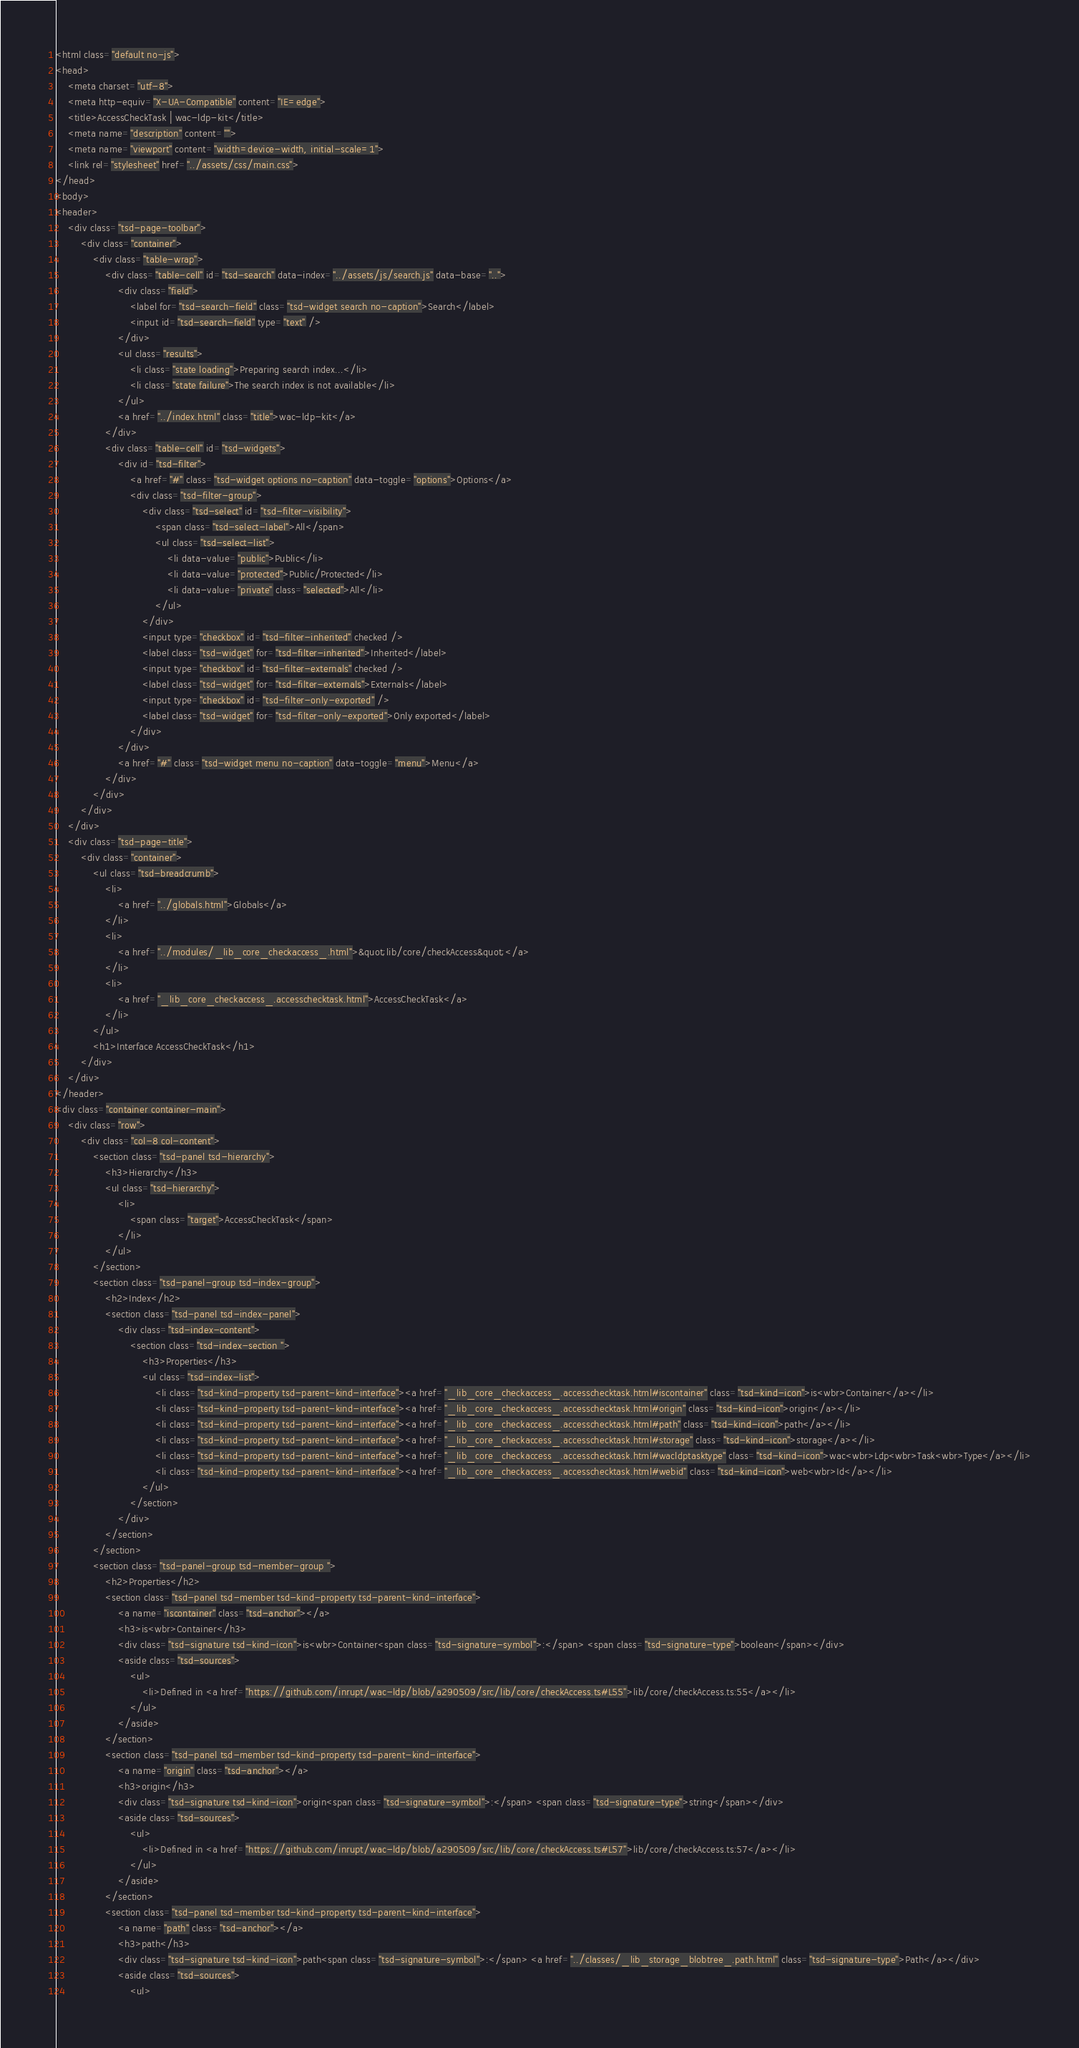Convert code to text. <code><loc_0><loc_0><loc_500><loc_500><_HTML_><html class="default no-js">
<head>
	<meta charset="utf-8">
	<meta http-equiv="X-UA-Compatible" content="IE=edge">
	<title>AccessCheckTask | wac-ldp-kit</title>
	<meta name="description" content="">
	<meta name="viewport" content="width=device-width, initial-scale=1">
	<link rel="stylesheet" href="../assets/css/main.css">
</head>
<body>
<header>
	<div class="tsd-page-toolbar">
		<div class="container">
			<div class="table-wrap">
				<div class="table-cell" id="tsd-search" data-index="../assets/js/search.js" data-base="..">
					<div class="field">
						<label for="tsd-search-field" class="tsd-widget search no-caption">Search</label>
						<input id="tsd-search-field" type="text" />
					</div>
					<ul class="results">
						<li class="state loading">Preparing search index...</li>
						<li class="state failure">The search index is not available</li>
					</ul>
					<a href="../index.html" class="title">wac-ldp-kit</a>
				</div>
				<div class="table-cell" id="tsd-widgets">
					<div id="tsd-filter">
						<a href="#" class="tsd-widget options no-caption" data-toggle="options">Options</a>
						<div class="tsd-filter-group">
							<div class="tsd-select" id="tsd-filter-visibility">
								<span class="tsd-select-label">All</span>
								<ul class="tsd-select-list">
									<li data-value="public">Public</li>
									<li data-value="protected">Public/Protected</li>
									<li data-value="private" class="selected">All</li>
								</ul>
							</div>
							<input type="checkbox" id="tsd-filter-inherited" checked />
							<label class="tsd-widget" for="tsd-filter-inherited">Inherited</label>
							<input type="checkbox" id="tsd-filter-externals" checked />
							<label class="tsd-widget" for="tsd-filter-externals">Externals</label>
							<input type="checkbox" id="tsd-filter-only-exported" />
							<label class="tsd-widget" for="tsd-filter-only-exported">Only exported</label>
						</div>
					</div>
					<a href="#" class="tsd-widget menu no-caption" data-toggle="menu">Menu</a>
				</div>
			</div>
		</div>
	</div>
	<div class="tsd-page-title">
		<div class="container">
			<ul class="tsd-breadcrumb">
				<li>
					<a href="../globals.html">Globals</a>
				</li>
				<li>
					<a href="../modules/_lib_core_checkaccess_.html">&quot;lib/core/checkAccess&quot;</a>
				</li>
				<li>
					<a href="_lib_core_checkaccess_.accesschecktask.html">AccessCheckTask</a>
				</li>
			</ul>
			<h1>Interface AccessCheckTask</h1>
		</div>
	</div>
</header>
<div class="container container-main">
	<div class="row">
		<div class="col-8 col-content">
			<section class="tsd-panel tsd-hierarchy">
				<h3>Hierarchy</h3>
				<ul class="tsd-hierarchy">
					<li>
						<span class="target">AccessCheckTask</span>
					</li>
				</ul>
			</section>
			<section class="tsd-panel-group tsd-index-group">
				<h2>Index</h2>
				<section class="tsd-panel tsd-index-panel">
					<div class="tsd-index-content">
						<section class="tsd-index-section ">
							<h3>Properties</h3>
							<ul class="tsd-index-list">
								<li class="tsd-kind-property tsd-parent-kind-interface"><a href="_lib_core_checkaccess_.accesschecktask.html#iscontainer" class="tsd-kind-icon">is<wbr>Container</a></li>
								<li class="tsd-kind-property tsd-parent-kind-interface"><a href="_lib_core_checkaccess_.accesschecktask.html#origin" class="tsd-kind-icon">origin</a></li>
								<li class="tsd-kind-property tsd-parent-kind-interface"><a href="_lib_core_checkaccess_.accesschecktask.html#path" class="tsd-kind-icon">path</a></li>
								<li class="tsd-kind-property tsd-parent-kind-interface"><a href="_lib_core_checkaccess_.accesschecktask.html#storage" class="tsd-kind-icon">storage</a></li>
								<li class="tsd-kind-property tsd-parent-kind-interface"><a href="_lib_core_checkaccess_.accesschecktask.html#wacldptasktype" class="tsd-kind-icon">wac<wbr>Ldp<wbr>Task<wbr>Type</a></li>
								<li class="tsd-kind-property tsd-parent-kind-interface"><a href="_lib_core_checkaccess_.accesschecktask.html#webid" class="tsd-kind-icon">web<wbr>Id</a></li>
							</ul>
						</section>
					</div>
				</section>
			</section>
			<section class="tsd-panel-group tsd-member-group ">
				<h2>Properties</h2>
				<section class="tsd-panel tsd-member tsd-kind-property tsd-parent-kind-interface">
					<a name="iscontainer" class="tsd-anchor"></a>
					<h3>is<wbr>Container</h3>
					<div class="tsd-signature tsd-kind-icon">is<wbr>Container<span class="tsd-signature-symbol">:</span> <span class="tsd-signature-type">boolean</span></div>
					<aside class="tsd-sources">
						<ul>
							<li>Defined in <a href="https://github.com/inrupt/wac-ldp/blob/a290509/src/lib/core/checkAccess.ts#L55">lib/core/checkAccess.ts:55</a></li>
						</ul>
					</aside>
				</section>
				<section class="tsd-panel tsd-member tsd-kind-property tsd-parent-kind-interface">
					<a name="origin" class="tsd-anchor"></a>
					<h3>origin</h3>
					<div class="tsd-signature tsd-kind-icon">origin<span class="tsd-signature-symbol">:</span> <span class="tsd-signature-type">string</span></div>
					<aside class="tsd-sources">
						<ul>
							<li>Defined in <a href="https://github.com/inrupt/wac-ldp/blob/a290509/src/lib/core/checkAccess.ts#L57">lib/core/checkAccess.ts:57</a></li>
						</ul>
					</aside>
				</section>
				<section class="tsd-panel tsd-member tsd-kind-property tsd-parent-kind-interface">
					<a name="path" class="tsd-anchor"></a>
					<h3>path</h3>
					<div class="tsd-signature tsd-kind-icon">path<span class="tsd-signature-symbol">:</span> <a href="../classes/_lib_storage_blobtree_.path.html" class="tsd-signature-type">Path</a></div>
					<aside class="tsd-sources">
						<ul></code> 